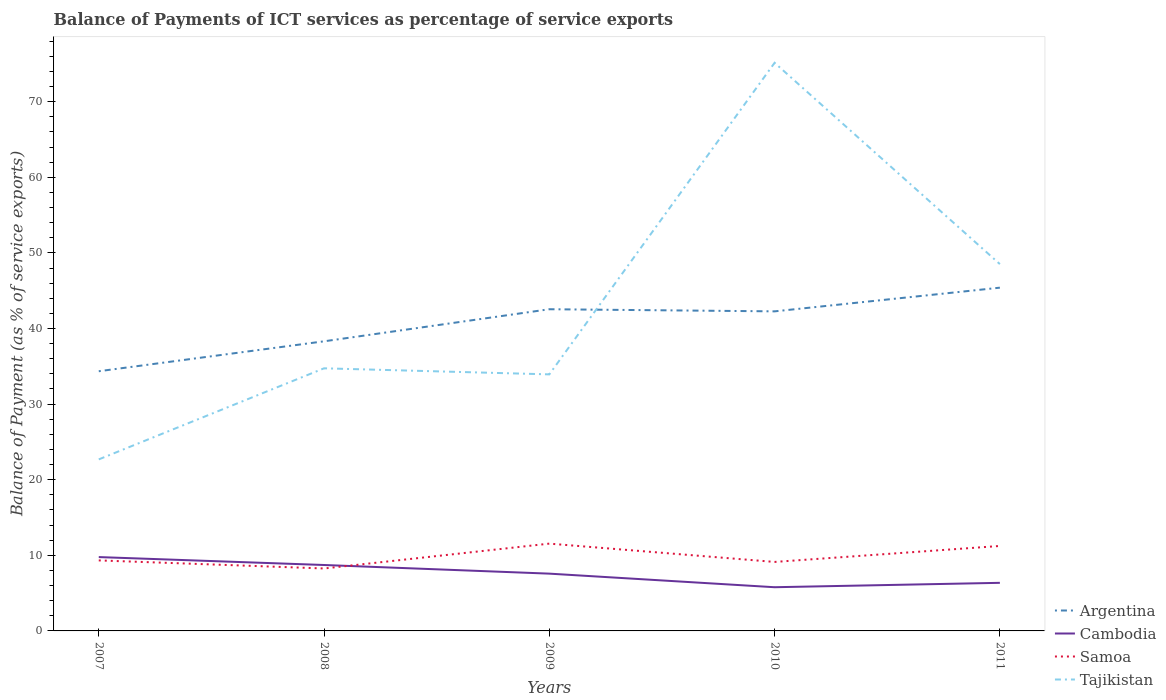Across all years, what is the maximum balance of payments of ICT services in Samoa?
Provide a succinct answer. 8.26. What is the total balance of payments of ICT services in Samoa in the graph?
Offer a terse response. -0.87. What is the difference between the highest and the second highest balance of payments of ICT services in Tajikistan?
Your answer should be compact. 52.46. Is the balance of payments of ICT services in Argentina strictly greater than the balance of payments of ICT services in Tajikistan over the years?
Make the answer very short. No. Are the values on the major ticks of Y-axis written in scientific E-notation?
Your answer should be compact. No. Does the graph contain any zero values?
Your response must be concise. No. How many legend labels are there?
Keep it short and to the point. 4. What is the title of the graph?
Keep it short and to the point. Balance of Payments of ICT services as percentage of service exports. Does "Indonesia" appear as one of the legend labels in the graph?
Provide a succinct answer. No. What is the label or title of the X-axis?
Your answer should be very brief. Years. What is the label or title of the Y-axis?
Ensure brevity in your answer.  Balance of Payment (as % of service exports). What is the Balance of Payment (as % of service exports) in Argentina in 2007?
Your response must be concise. 34.35. What is the Balance of Payment (as % of service exports) in Cambodia in 2007?
Make the answer very short. 9.77. What is the Balance of Payment (as % of service exports) in Samoa in 2007?
Ensure brevity in your answer.  9.33. What is the Balance of Payment (as % of service exports) of Tajikistan in 2007?
Your answer should be very brief. 22.69. What is the Balance of Payment (as % of service exports) of Argentina in 2008?
Your response must be concise. 38.31. What is the Balance of Payment (as % of service exports) in Cambodia in 2008?
Provide a succinct answer. 8.72. What is the Balance of Payment (as % of service exports) in Samoa in 2008?
Give a very brief answer. 8.26. What is the Balance of Payment (as % of service exports) in Tajikistan in 2008?
Give a very brief answer. 34.74. What is the Balance of Payment (as % of service exports) of Argentina in 2009?
Keep it short and to the point. 42.55. What is the Balance of Payment (as % of service exports) in Cambodia in 2009?
Provide a short and direct response. 7.58. What is the Balance of Payment (as % of service exports) of Samoa in 2009?
Offer a terse response. 11.55. What is the Balance of Payment (as % of service exports) of Tajikistan in 2009?
Offer a very short reply. 33.93. What is the Balance of Payment (as % of service exports) in Argentina in 2010?
Your response must be concise. 42.27. What is the Balance of Payment (as % of service exports) of Cambodia in 2010?
Offer a terse response. 5.78. What is the Balance of Payment (as % of service exports) in Samoa in 2010?
Your answer should be very brief. 9.13. What is the Balance of Payment (as % of service exports) in Tajikistan in 2010?
Ensure brevity in your answer.  75.15. What is the Balance of Payment (as % of service exports) in Argentina in 2011?
Offer a very short reply. 45.4. What is the Balance of Payment (as % of service exports) of Cambodia in 2011?
Offer a very short reply. 6.36. What is the Balance of Payment (as % of service exports) of Samoa in 2011?
Offer a very short reply. 11.24. What is the Balance of Payment (as % of service exports) of Tajikistan in 2011?
Give a very brief answer. 48.52. Across all years, what is the maximum Balance of Payment (as % of service exports) in Argentina?
Keep it short and to the point. 45.4. Across all years, what is the maximum Balance of Payment (as % of service exports) in Cambodia?
Offer a very short reply. 9.77. Across all years, what is the maximum Balance of Payment (as % of service exports) in Samoa?
Make the answer very short. 11.55. Across all years, what is the maximum Balance of Payment (as % of service exports) of Tajikistan?
Offer a very short reply. 75.15. Across all years, what is the minimum Balance of Payment (as % of service exports) of Argentina?
Give a very brief answer. 34.35. Across all years, what is the minimum Balance of Payment (as % of service exports) in Cambodia?
Provide a succinct answer. 5.78. Across all years, what is the minimum Balance of Payment (as % of service exports) in Samoa?
Keep it short and to the point. 8.26. Across all years, what is the minimum Balance of Payment (as % of service exports) of Tajikistan?
Offer a very short reply. 22.69. What is the total Balance of Payment (as % of service exports) in Argentina in the graph?
Your answer should be compact. 202.88. What is the total Balance of Payment (as % of service exports) in Cambodia in the graph?
Make the answer very short. 38.2. What is the total Balance of Payment (as % of service exports) of Samoa in the graph?
Give a very brief answer. 49.5. What is the total Balance of Payment (as % of service exports) in Tajikistan in the graph?
Provide a short and direct response. 215.03. What is the difference between the Balance of Payment (as % of service exports) of Argentina in 2007 and that in 2008?
Offer a very short reply. -3.96. What is the difference between the Balance of Payment (as % of service exports) in Cambodia in 2007 and that in 2008?
Keep it short and to the point. 1.05. What is the difference between the Balance of Payment (as % of service exports) of Samoa in 2007 and that in 2008?
Provide a succinct answer. 1.07. What is the difference between the Balance of Payment (as % of service exports) of Tajikistan in 2007 and that in 2008?
Your answer should be very brief. -12.05. What is the difference between the Balance of Payment (as % of service exports) of Argentina in 2007 and that in 2009?
Your response must be concise. -8.2. What is the difference between the Balance of Payment (as % of service exports) in Cambodia in 2007 and that in 2009?
Provide a succinct answer. 2.19. What is the difference between the Balance of Payment (as % of service exports) in Samoa in 2007 and that in 2009?
Your answer should be compact. -2.22. What is the difference between the Balance of Payment (as % of service exports) in Tajikistan in 2007 and that in 2009?
Your answer should be very brief. -11.25. What is the difference between the Balance of Payment (as % of service exports) in Argentina in 2007 and that in 2010?
Offer a terse response. -7.92. What is the difference between the Balance of Payment (as % of service exports) of Cambodia in 2007 and that in 2010?
Offer a very short reply. 3.99. What is the difference between the Balance of Payment (as % of service exports) of Samoa in 2007 and that in 2010?
Keep it short and to the point. 0.2. What is the difference between the Balance of Payment (as % of service exports) in Tajikistan in 2007 and that in 2010?
Provide a short and direct response. -52.46. What is the difference between the Balance of Payment (as % of service exports) of Argentina in 2007 and that in 2011?
Provide a short and direct response. -11.05. What is the difference between the Balance of Payment (as % of service exports) of Cambodia in 2007 and that in 2011?
Ensure brevity in your answer.  3.41. What is the difference between the Balance of Payment (as % of service exports) of Samoa in 2007 and that in 2011?
Make the answer very short. -1.91. What is the difference between the Balance of Payment (as % of service exports) in Tajikistan in 2007 and that in 2011?
Keep it short and to the point. -25.83. What is the difference between the Balance of Payment (as % of service exports) in Argentina in 2008 and that in 2009?
Give a very brief answer. -4.24. What is the difference between the Balance of Payment (as % of service exports) in Cambodia in 2008 and that in 2009?
Your answer should be compact. 1.14. What is the difference between the Balance of Payment (as % of service exports) in Samoa in 2008 and that in 2009?
Offer a very short reply. -3.29. What is the difference between the Balance of Payment (as % of service exports) of Tajikistan in 2008 and that in 2009?
Provide a succinct answer. 0.8. What is the difference between the Balance of Payment (as % of service exports) in Argentina in 2008 and that in 2010?
Offer a very short reply. -3.96. What is the difference between the Balance of Payment (as % of service exports) in Cambodia in 2008 and that in 2010?
Offer a terse response. 2.94. What is the difference between the Balance of Payment (as % of service exports) in Samoa in 2008 and that in 2010?
Your answer should be compact. -0.87. What is the difference between the Balance of Payment (as % of service exports) of Tajikistan in 2008 and that in 2010?
Provide a short and direct response. -40.41. What is the difference between the Balance of Payment (as % of service exports) in Argentina in 2008 and that in 2011?
Keep it short and to the point. -7.09. What is the difference between the Balance of Payment (as % of service exports) in Cambodia in 2008 and that in 2011?
Keep it short and to the point. 2.36. What is the difference between the Balance of Payment (as % of service exports) in Samoa in 2008 and that in 2011?
Provide a short and direct response. -2.98. What is the difference between the Balance of Payment (as % of service exports) of Tajikistan in 2008 and that in 2011?
Ensure brevity in your answer.  -13.78. What is the difference between the Balance of Payment (as % of service exports) in Argentina in 2009 and that in 2010?
Your response must be concise. 0.28. What is the difference between the Balance of Payment (as % of service exports) in Cambodia in 2009 and that in 2010?
Provide a succinct answer. 1.8. What is the difference between the Balance of Payment (as % of service exports) of Samoa in 2009 and that in 2010?
Your response must be concise. 2.42. What is the difference between the Balance of Payment (as % of service exports) in Tajikistan in 2009 and that in 2010?
Ensure brevity in your answer.  -41.21. What is the difference between the Balance of Payment (as % of service exports) in Argentina in 2009 and that in 2011?
Keep it short and to the point. -2.85. What is the difference between the Balance of Payment (as % of service exports) of Cambodia in 2009 and that in 2011?
Your response must be concise. 1.21. What is the difference between the Balance of Payment (as % of service exports) of Samoa in 2009 and that in 2011?
Ensure brevity in your answer.  0.31. What is the difference between the Balance of Payment (as % of service exports) of Tajikistan in 2009 and that in 2011?
Your answer should be compact. -14.58. What is the difference between the Balance of Payment (as % of service exports) of Argentina in 2010 and that in 2011?
Give a very brief answer. -3.13. What is the difference between the Balance of Payment (as % of service exports) in Cambodia in 2010 and that in 2011?
Provide a short and direct response. -0.58. What is the difference between the Balance of Payment (as % of service exports) of Samoa in 2010 and that in 2011?
Your answer should be compact. -2.11. What is the difference between the Balance of Payment (as % of service exports) in Tajikistan in 2010 and that in 2011?
Your response must be concise. 26.63. What is the difference between the Balance of Payment (as % of service exports) of Argentina in 2007 and the Balance of Payment (as % of service exports) of Cambodia in 2008?
Keep it short and to the point. 25.63. What is the difference between the Balance of Payment (as % of service exports) of Argentina in 2007 and the Balance of Payment (as % of service exports) of Samoa in 2008?
Your response must be concise. 26.09. What is the difference between the Balance of Payment (as % of service exports) of Argentina in 2007 and the Balance of Payment (as % of service exports) of Tajikistan in 2008?
Provide a short and direct response. -0.39. What is the difference between the Balance of Payment (as % of service exports) of Cambodia in 2007 and the Balance of Payment (as % of service exports) of Samoa in 2008?
Make the answer very short. 1.51. What is the difference between the Balance of Payment (as % of service exports) of Cambodia in 2007 and the Balance of Payment (as % of service exports) of Tajikistan in 2008?
Your answer should be very brief. -24.97. What is the difference between the Balance of Payment (as % of service exports) in Samoa in 2007 and the Balance of Payment (as % of service exports) in Tajikistan in 2008?
Ensure brevity in your answer.  -25.41. What is the difference between the Balance of Payment (as % of service exports) of Argentina in 2007 and the Balance of Payment (as % of service exports) of Cambodia in 2009?
Offer a very short reply. 26.77. What is the difference between the Balance of Payment (as % of service exports) of Argentina in 2007 and the Balance of Payment (as % of service exports) of Samoa in 2009?
Your answer should be very brief. 22.8. What is the difference between the Balance of Payment (as % of service exports) in Argentina in 2007 and the Balance of Payment (as % of service exports) in Tajikistan in 2009?
Keep it short and to the point. 0.41. What is the difference between the Balance of Payment (as % of service exports) in Cambodia in 2007 and the Balance of Payment (as % of service exports) in Samoa in 2009?
Offer a terse response. -1.78. What is the difference between the Balance of Payment (as % of service exports) of Cambodia in 2007 and the Balance of Payment (as % of service exports) of Tajikistan in 2009?
Keep it short and to the point. -24.17. What is the difference between the Balance of Payment (as % of service exports) of Samoa in 2007 and the Balance of Payment (as % of service exports) of Tajikistan in 2009?
Provide a succinct answer. -24.61. What is the difference between the Balance of Payment (as % of service exports) of Argentina in 2007 and the Balance of Payment (as % of service exports) of Cambodia in 2010?
Your response must be concise. 28.57. What is the difference between the Balance of Payment (as % of service exports) of Argentina in 2007 and the Balance of Payment (as % of service exports) of Samoa in 2010?
Offer a terse response. 25.22. What is the difference between the Balance of Payment (as % of service exports) of Argentina in 2007 and the Balance of Payment (as % of service exports) of Tajikistan in 2010?
Offer a very short reply. -40.8. What is the difference between the Balance of Payment (as % of service exports) of Cambodia in 2007 and the Balance of Payment (as % of service exports) of Samoa in 2010?
Make the answer very short. 0.64. What is the difference between the Balance of Payment (as % of service exports) in Cambodia in 2007 and the Balance of Payment (as % of service exports) in Tajikistan in 2010?
Offer a terse response. -65.38. What is the difference between the Balance of Payment (as % of service exports) of Samoa in 2007 and the Balance of Payment (as % of service exports) of Tajikistan in 2010?
Ensure brevity in your answer.  -65.82. What is the difference between the Balance of Payment (as % of service exports) of Argentina in 2007 and the Balance of Payment (as % of service exports) of Cambodia in 2011?
Make the answer very short. 27.99. What is the difference between the Balance of Payment (as % of service exports) of Argentina in 2007 and the Balance of Payment (as % of service exports) of Samoa in 2011?
Give a very brief answer. 23.11. What is the difference between the Balance of Payment (as % of service exports) in Argentina in 2007 and the Balance of Payment (as % of service exports) in Tajikistan in 2011?
Ensure brevity in your answer.  -14.17. What is the difference between the Balance of Payment (as % of service exports) in Cambodia in 2007 and the Balance of Payment (as % of service exports) in Samoa in 2011?
Offer a terse response. -1.47. What is the difference between the Balance of Payment (as % of service exports) in Cambodia in 2007 and the Balance of Payment (as % of service exports) in Tajikistan in 2011?
Ensure brevity in your answer.  -38.75. What is the difference between the Balance of Payment (as % of service exports) of Samoa in 2007 and the Balance of Payment (as % of service exports) of Tajikistan in 2011?
Your response must be concise. -39.19. What is the difference between the Balance of Payment (as % of service exports) in Argentina in 2008 and the Balance of Payment (as % of service exports) in Cambodia in 2009?
Keep it short and to the point. 30.73. What is the difference between the Balance of Payment (as % of service exports) of Argentina in 2008 and the Balance of Payment (as % of service exports) of Samoa in 2009?
Offer a very short reply. 26.76. What is the difference between the Balance of Payment (as % of service exports) of Argentina in 2008 and the Balance of Payment (as % of service exports) of Tajikistan in 2009?
Your answer should be compact. 4.37. What is the difference between the Balance of Payment (as % of service exports) in Cambodia in 2008 and the Balance of Payment (as % of service exports) in Samoa in 2009?
Provide a short and direct response. -2.83. What is the difference between the Balance of Payment (as % of service exports) in Cambodia in 2008 and the Balance of Payment (as % of service exports) in Tajikistan in 2009?
Ensure brevity in your answer.  -25.22. What is the difference between the Balance of Payment (as % of service exports) of Samoa in 2008 and the Balance of Payment (as % of service exports) of Tajikistan in 2009?
Your answer should be very brief. -25.68. What is the difference between the Balance of Payment (as % of service exports) in Argentina in 2008 and the Balance of Payment (as % of service exports) in Cambodia in 2010?
Provide a short and direct response. 32.53. What is the difference between the Balance of Payment (as % of service exports) of Argentina in 2008 and the Balance of Payment (as % of service exports) of Samoa in 2010?
Your answer should be very brief. 29.18. What is the difference between the Balance of Payment (as % of service exports) of Argentina in 2008 and the Balance of Payment (as % of service exports) of Tajikistan in 2010?
Ensure brevity in your answer.  -36.84. What is the difference between the Balance of Payment (as % of service exports) in Cambodia in 2008 and the Balance of Payment (as % of service exports) in Samoa in 2010?
Give a very brief answer. -0.41. What is the difference between the Balance of Payment (as % of service exports) of Cambodia in 2008 and the Balance of Payment (as % of service exports) of Tajikistan in 2010?
Provide a succinct answer. -66.43. What is the difference between the Balance of Payment (as % of service exports) of Samoa in 2008 and the Balance of Payment (as % of service exports) of Tajikistan in 2010?
Your answer should be very brief. -66.89. What is the difference between the Balance of Payment (as % of service exports) in Argentina in 2008 and the Balance of Payment (as % of service exports) in Cambodia in 2011?
Offer a very short reply. 31.95. What is the difference between the Balance of Payment (as % of service exports) of Argentina in 2008 and the Balance of Payment (as % of service exports) of Samoa in 2011?
Ensure brevity in your answer.  27.07. What is the difference between the Balance of Payment (as % of service exports) in Argentina in 2008 and the Balance of Payment (as % of service exports) in Tajikistan in 2011?
Offer a very short reply. -10.21. What is the difference between the Balance of Payment (as % of service exports) of Cambodia in 2008 and the Balance of Payment (as % of service exports) of Samoa in 2011?
Offer a terse response. -2.52. What is the difference between the Balance of Payment (as % of service exports) in Cambodia in 2008 and the Balance of Payment (as % of service exports) in Tajikistan in 2011?
Your answer should be compact. -39.8. What is the difference between the Balance of Payment (as % of service exports) of Samoa in 2008 and the Balance of Payment (as % of service exports) of Tajikistan in 2011?
Give a very brief answer. -40.26. What is the difference between the Balance of Payment (as % of service exports) in Argentina in 2009 and the Balance of Payment (as % of service exports) in Cambodia in 2010?
Your answer should be compact. 36.77. What is the difference between the Balance of Payment (as % of service exports) in Argentina in 2009 and the Balance of Payment (as % of service exports) in Samoa in 2010?
Ensure brevity in your answer.  33.43. What is the difference between the Balance of Payment (as % of service exports) of Argentina in 2009 and the Balance of Payment (as % of service exports) of Tajikistan in 2010?
Keep it short and to the point. -32.6. What is the difference between the Balance of Payment (as % of service exports) in Cambodia in 2009 and the Balance of Payment (as % of service exports) in Samoa in 2010?
Make the answer very short. -1.55. What is the difference between the Balance of Payment (as % of service exports) in Cambodia in 2009 and the Balance of Payment (as % of service exports) in Tajikistan in 2010?
Offer a terse response. -67.57. What is the difference between the Balance of Payment (as % of service exports) in Samoa in 2009 and the Balance of Payment (as % of service exports) in Tajikistan in 2010?
Keep it short and to the point. -63.6. What is the difference between the Balance of Payment (as % of service exports) of Argentina in 2009 and the Balance of Payment (as % of service exports) of Cambodia in 2011?
Give a very brief answer. 36.19. What is the difference between the Balance of Payment (as % of service exports) of Argentina in 2009 and the Balance of Payment (as % of service exports) of Samoa in 2011?
Offer a terse response. 31.31. What is the difference between the Balance of Payment (as % of service exports) in Argentina in 2009 and the Balance of Payment (as % of service exports) in Tajikistan in 2011?
Provide a succinct answer. -5.97. What is the difference between the Balance of Payment (as % of service exports) in Cambodia in 2009 and the Balance of Payment (as % of service exports) in Samoa in 2011?
Provide a succinct answer. -3.66. What is the difference between the Balance of Payment (as % of service exports) in Cambodia in 2009 and the Balance of Payment (as % of service exports) in Tajikistan in 2011?
Provide a short and direct response. -40.94. What is the difference between the Balance of Payment (as % of service exports) in Samoa in 2009 and the Balance of Payment (as % of service exports) in Tajikistan in 2011?
Provide a succinct answer. -36.97. What is the difference between the Balance of Payment (as % of service exports) of Argentina in 2010 and the Balance of Payment (as % of service exports) of Cambodia in 2011?
Offer a terse response. 35.91. What is the difference between the Balance of Payment (as % of service exports) of Argentina in 2010 and the Balance of Payment (as % of service exports) of Samoa in 2011?
Your answer should be compact. 31.03. What is the difference between the Balance of Payment (as % of service exports) in Argentina in 2010 and the Balance of Payment (as % of service exports) in Tajikistan in 2011?
Your answer should be very brief. -6.25. What is the difference between the Balance of Payment (as % of service exports) in Cambodia in 2010 and the Balance of Payment (as % of service exports) in Samoa in 2011?
Ensure brevity in your answer.  -5.46. What is the difference between the Balance of Payment (as % of service exports) in Cambodia in 2010 and the Balance of Payment (as % of service exports) in Tajikistan in 2011?
Provide a succinct answer. -42.74. What is the difference between the Balance of Payment (as % of service exports) in Samoa in 2010 and the Balance of Payment (as % of service exports) in Tajikistan in 2011?
Offer a terse response. -39.39. What is the average Balance of Payment (as % of service exports) of Argentina per year?
Make the answer very short. 40.58. What is the average Balance of Payment (as % of service exports) of Cambodia per year?
Make the answer very short. 7.64. What is the average Balance of Payment (as % of service exports) in Samoa per year?
Ensure brevity in your answer.  9.9. What is the average Balance of Payment (as % of service exports) in Tajikistan per year?
Keep it short and to the point. 43.01. In the year 2007, what is the difference between the Balance of Payment (as % of service exports) of Argentina and Balance of Payment (as % of service exports) of Cambodia?
Offer a terse response. 24.58. In the year 2007, what is the difference between the Balance of Payment (as % of service exports) of Argentina and Balance of Payment (as % of service exports) of Samoa?
Ensure brevity in your answer.  25.02. In the year 2007, what is the difference between the Balance of Payment (as % of service exports) in Argentina and Balance of Payment (as % of service exports) in Tajikistan?
Give a very brief answer. 11.66. In the year 2007, what is the difference between the Balance of Payment (as % of service exports) of Cambodia and Balance of Payment (as % of service exports) of Samoa?
Give a very brief answer. 0.44. In the year 2007, what is the difference between the Balance of Payment (as % of service exports) of Cambodia and Balance of Payment (as % of service exports) of Tajikistan?
Give a very brief answer. -12.92. In the year 2007, what is the difference between the Balance of Payment (as % of service exports) in Samoa and Balance of Payment (as % of service exports) in Tajikistan?
Offer a very short reply. -13.36. In the year 2008, what is the difference between the Balance of Payment (as % of service exports) of Argentina and Balance of Payment (as % of service exports) of Cambodia?
Make the answer very short. 29.59. In the year 2008, what is the difference between the Balance of Payment (as % of service exports) of Argentina and Balance of Payment (as % of service exports) of Samoa?
Keep it short and to the point. 30.05. In the year 2008, what is the difference between the Balance of Payment (as % of service exports) in Argentina and Balance of Payment (as % of service exports) in Tajikistan?
Make the answer very short. 3.57. In the year 2008, what is the difference between the Balance of Payment (as % of service exports) in Cambodia and Balance of Payment (as % of service exports) in Samoa?
Your response must be concise. 0.46. In the year 2008, what is the difference between the Balance of Payment (as % of service exports) in Cambodia and Balance of Payment (as % of service exports) in Tajikistan?
Offer a very short reply. -26.02. In the year 2008, what is the difference between the Balance of Payment (as % of service exports) of Samoa and Balance of Payment (as % of service exports) of Tajikistan?
Provide a succinct answer. -26.48. In the year 2009, what is the difference between the Balance of Payment (as % of service exports) of Argentina and Balance of Payment (as % of service exports) of Cambodia?
Give a very brief answer. 34.97. In the year 2009, what is the difference between the Balance of Payment (as % of service exports) in Argentina and Balance of Payment (as % of service exports) in Samoa?
Keep it short and to the point. 31. In the year 2009, what is the difference between the Balance of Payment (as % of service exports) of Argentina and Balance of Payment (as % of service exports) of Tajikistan?
Make the answer very short. 8.62. In the year 2009, what is the difference between the Balance of Payment (as % of service exports) of Cambodia and Balance of Payment (as % of service exports) of Samoa?
Make the answer very short. -3.97. In the year 2009, what is the difference between the Balance of Payment (as % of service exports) of Cambodia and Balance of Payment (as % of service exports) of Tajikistan?
Provide a short and direct response. -26.36. In the year 2009, what is the difference between the Balance of Payment (as % of service exports) in Samoa and Balance of Payment (as % of service exports) in Tajikistan?
Your response must be concise. -22.39. In the year 2010, what is the difference between the Balance of Payment (as % of service exports) in Argentina and Balance of Payment (as % of service exports) in Cambodia?
Offer a terse response. 36.49. In the year 2010, what is the difference between the Balance of Payment (as % of service exports) of Argentina and Balance of Payment (as % of service exports) of Samoa?
Offer a very short reply. 33.14. In the year 2010, what is the difference between the Balance of Payment (as % of service exports) in Argentina and Balance of Payment (as % of service exports) in Tajikistan?
Keep it short and to the point. -32.88. In the year 2010, what is the difference between the Balance of Payment (as % of service exports) in Cambodia and Balance of Payment (as % of service exports) in Samoa?
Your answer should be very brief. -3.35. In the year 2010, what is the difference between the Balance of Payment (as % of service exports) of Cambodia and Balance of Payment (as % of service exports) of Tajikistan?
Provide a short and direct response. -69.37. In the year 2010, what is the difference between the Balance of Payment (as % of service exports) in Samoa and Balance of Payment (as % of service exports) in Tajikistan?
Provide a short and direct response. -66.02. In the year 2011, what is the difference between the Balance of Payment (as % of service exports) in Argentina and Balance of Payment (as % of service exports) in Cambodia?
Offer a very short reply. 39.04. In the year 2011, what is the difference between the Balance of Payment (as % of service exports) in Argentina and Balance of Payment (as % of service exports) in Samoa?
Your response must be concise. 34.16. In the year 2011, what is the difference between the Balance of Payment (as % of service exports) in Argentina and Balance of Payment (as % of service exports) in Tajikistan?
Make the answer very short. -3.12. In the year 2011, what is the difference between the Balance of Payment (as % of service exports) of Cambodia and Balance of Payment (as % of service exports) of Samoa?
Your response must be concise. -4.88. In the year 2011, what is the difference between the Balance of Payment (as % of service exports) of Cambodia and Balance of Payment (as % of service exports) of Tajikistan?
Your response must be concise. -42.16. In the year 2011, what is the difference between the Balance of Payment (as % of service exports) in Samoa and Balance of Payment (as % of service exports) in Tajikistan?
Provide a short and direct response. -37.28. What is the ratio of the Balance of Payment (as % of service exports) of Argentina in 2007 to that in 2008?
Make the answer very short. 0.9. What is the ratio of the Balance of Payment (as % of service exports) in Cambodia in 2007 to that in 2008?
Your answer should be very brief. 1.12. What is the ratio of the Balance of Payment (as % of service exports) in Samoa in 2007 to that in 2008?
Give a very brief answer. 1.13. What is the ratio of the Balance of Payment (as % of service exports) of Tajikistan in 2007 to that in 2008?
Your response must be concise. 0.65. What is the ratio of the Balance of Payment (as % of service exports) in Argentina in 2007 to that in 2009?
Offer a terse response. 0.81. What is the ratio of the Balance of Payment (as % of service exports) of Cambodia in 2007 to that in 2009?
Keep it short and to the point. 1.29. What is the ratio of the Balance of Payment (as % of service exports) in Samoa in 2007 to that in 2009?
Ensure brevity in your answer.  0.81. What is the ratio of the Balance of Payment (as % of service exports) in Tajikistan in 2007 to that in 2009?
Keep it short and to the point. 0.67. What is the ratio of the Balance of Payment (as % of service exports) in Argentina in 2007 to that in 2010?
Make the answer very short. 0.81. What is the ratio of the Balance of Payment (as % of service exports) of Cambodia in 2007 to that in 2010?
Your response must be concise. 1.69. What is the ratio of the Balance of Payment (as % of service exports) of Samoa in 2007 to that in 2010?
Make the answer very short. 1.02. What is the ratio of the Balance of Payment (as % of service exports) in Tajikistan in 2007 to that in 2010?
Provide a succinct answer. 0.3. What is the ratio of the Balance of Payment (as % of service exports) of Argentina in 2007 to that in 2011?
Provide a short and direct response. 0.76. What is the ratio of the Balance of Payment (as % of service exports) of Cambodia in 2007 to that in 2011?
Ensure brevity in your answer.  1.54. What is the ratio of the Balance of Payment (as % of service exports) in Samoa in 2007 to that in 2011?
Your response must be concise. 0.83. What is the ratio of the Balance of Payment (as % of service exports) in Tajikistan in 2007 to that in 2011?
Your answer should be very brief. 0.47. What is the ratio of the Balance of Payment (as % of service exports) in Argentina in 2008 to that in 2009?
Provide a short and direct response. 0.9. What is the ratio of the Balance of Payment (as % of service exports) in Cambodia in 2008 to that in 2009?
Your answer should be compact. 1.15. What is the ratio of the Balance of Payment (as % of service exports) in Samoa in 2008 to that in 2009?
Offer a very short reply. 0.72. What is the ratio of the Balance of Payment (as % of service exports) in Tajikistan in 2008 to that in 2009?
Offer a terse response. 1.02. What is the ratio of the Balance of Payment (as % of service exports) in Argentina in 2008 to that in 2010?
Your answer should be very brief. 0.91. What is the ratio of the Balance of Payment (as % of service exports) of Cambodia in 2008 to that in 2010?
Keep it short and to the point. 1.51. What is the ratio of the Balance of Payment (as % of service exports) of Samoa in 2008 to that in 2010?
Your response must be concise. 0.91. What is the ratio of the Balance of Payment (as % of service exports) in Tajikistan in 2008 to that in 2010?
Offer a terse response. 0.46. What is the ratio of the Balance of Payment (as % of service exports) of Argentina in 2008 to that in 2011?
Keep it short and to the point. 0.84. What is the ratio of the Balance of Payment (as % of service exports) of Cambodia in 2008 to that in 2011?
Your response must be concise. 1.37. What is the ratio of the Balance of Payment (as % of service exports) in Samoa in 2008 to that in 2011?
Offer a very short reply. 0.73. What is the ratio of the Balance of Payment (as % of service exports) of Tajikistan in 2008 to that in 2011?
Your answer should be compact. 0.72. What is the ratio of the Balance of Payment (as % of service exports) of Argentina in 2009 to that in 2010?
Give a very brief answer. 1.01. What is the ratio of the Balance of Payment (as % of service exports) in Cambodia in 2009 to that in 2010?
Make the answer very short. 1.31. What is the ratio of the Balance of Payment (as % of service exports) of Samoa in 2009 to that in 2010?
Your answer should be very brief. 1.27. What is the ratio of the Balance of Payment (as % of service exports) in Tajikistan in 2009 to that in 2010?
Offer a terse response. 0.45. What is the ratio of the Balance of Payment (as % of service exports) of Argentina in 2009 to that in 2011?
Your answer should be very brief. 0.94. What is the ratio of the Balance of Payment (as % of service exports) in Cambodia in 2009 to that in 2011?
Provide a short and direct response. 1.19. What is the ratio of the Balance of Payment (as % of service exports) of Samoa in 2009 to that in 2011?
Provide a succinct answer. 1.03. What is the ratio of the Balance of Payment (as % of service exports) in Tajikistan in 2009 to that in 2011?
Make the answer very short. 0.7. What is the ratio of the Balance of Payment (as % of service exports) of Argentina in 2010 to that in 2011?
Make the answer very short. 0.93. What is the ratio of the Balance of Payment (as % of service exports) of Cambodia in 2010 to that in 2011?
Your answer should be compact. 0.91. What is the ratio of the Balance of Payment (as % of service exports) of Samoa in 2010 to that in 2011?
Make the answer very short. 0.81. What is the ratio of the Balance of Payment (as % of service exports) in Tajikistan in 2010 to that in 2011?
Make the answer very short. 1.55. What is the difference between the highest and the second highest Balance of Payment (as % of service exports) of Argentina?
Offer a very short reply. 2.85. What is the difference between the highest and the second highest Balance of Payment (as % of service exports) of Cambodia?
Ensure brevity in your answer.  1.05. What is the difference between the highest and the second highest Balance of Payment (as % of service exports) of Samoa?
Provide a succinct answer. 0.31. What is the difference between the highest and the second highest Balance of Payment (as % of service exports) of Tajikistan?
Keep it short and to the point. 26.63. What is the difference between the highest and the lowest Balance of Payment (as % of service exports) of Argentina?
Give a very brief answer. 11.05. What is the difference between the highest and the lowest Balance of Payment (as % of service exports) of Cambodia?
Offer a very short reply. 3.99. What is the difference between the highest and the lowest Balance of Payment (as % of service exports) in Samoa?
Provide a short and direct response. 3.29. What is the difference between the highest and the lowest Balance of Payment (as % of service exports) in Tajikistan?
Your response must be concise. 52.46. 